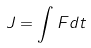<formula> <loc_0><loc_0><loc_500><loc_500>J = \int F d t</formula> 